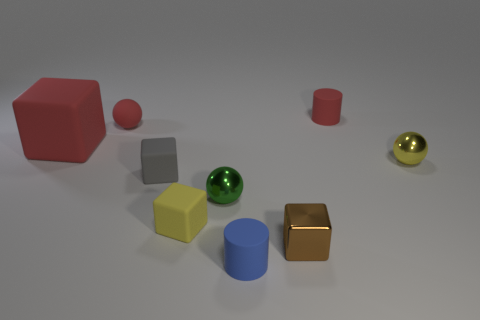How many things are brown metallic objects or small shiny things that are right of the tiny green metal object?
Offer a very short reply. 2. Is the size of the yellow matte block the same as the object that is in front of the brown metallic thing?
Make the answer very short. Yes. How many cylinders are either green metal things or big matte objects?
Give a very brief answer. 0. How many shiny things are both behind the small brown cube and in front of the yellow ball?
Provide a succinct answer. 1. What number of other things are the same color as the small matte ball?
Offer a terse response. 2. The small yellow object on the right side of the tiny yellow cube has what shape?
Ensure brevity in your answer.  Sphere. Are the small red sphere and the big object made of the same material?
Your response must be concise. Yes. Are there any other things that are the same size as the brown metallic block?
Make the answer very short. Yes. There is a rubber sphere; what number of tiny gray things are in front of it?
Provide a succinct answer. 1. The tiny metal thing in front of the metallic ball that is on the left side of the red cylinder is what shape?
Give a very brief answer. Cube. 